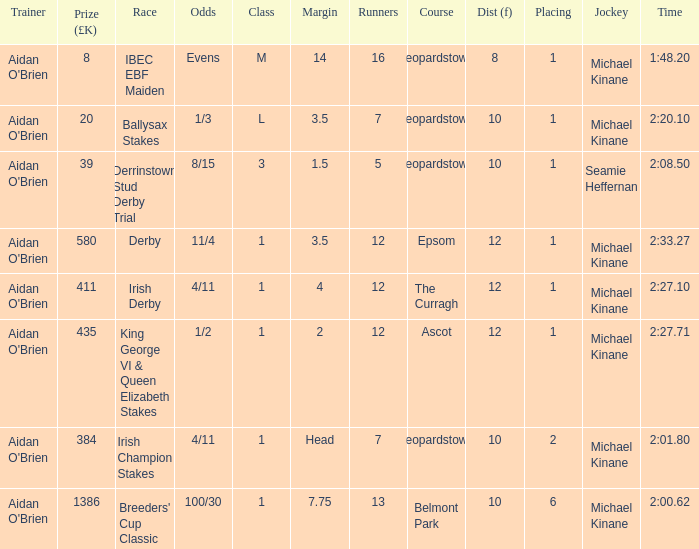Which Margin has a Dist (f) larger than 10, and a Race of king george vi & queen elizabeth stakes? 2.0. 